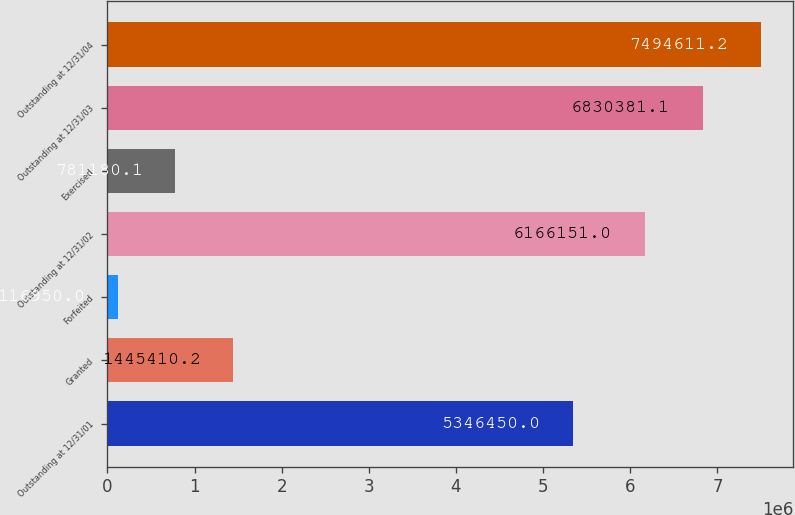Convert chart to OTSL. <chart><loc_0><loc_0><loc_500><loc_500><bar_chart><fcel>Outstanding at 12/31/01<fcel>Granted<fcel>Forfeited<fcel>Outstanding at 12/31/02<fcel>Exercised<fcel>Outstanding at 12/31/03<fcel>Outstanding at 12/31/04<nl><fcel>5.34645e+06<fcel>1.44541e+06<fcel>116950<fcel>6.16615e+06<fcel>781180<fcel>6.83038e+06<fcel>7.49461e+06<nl></chart> 